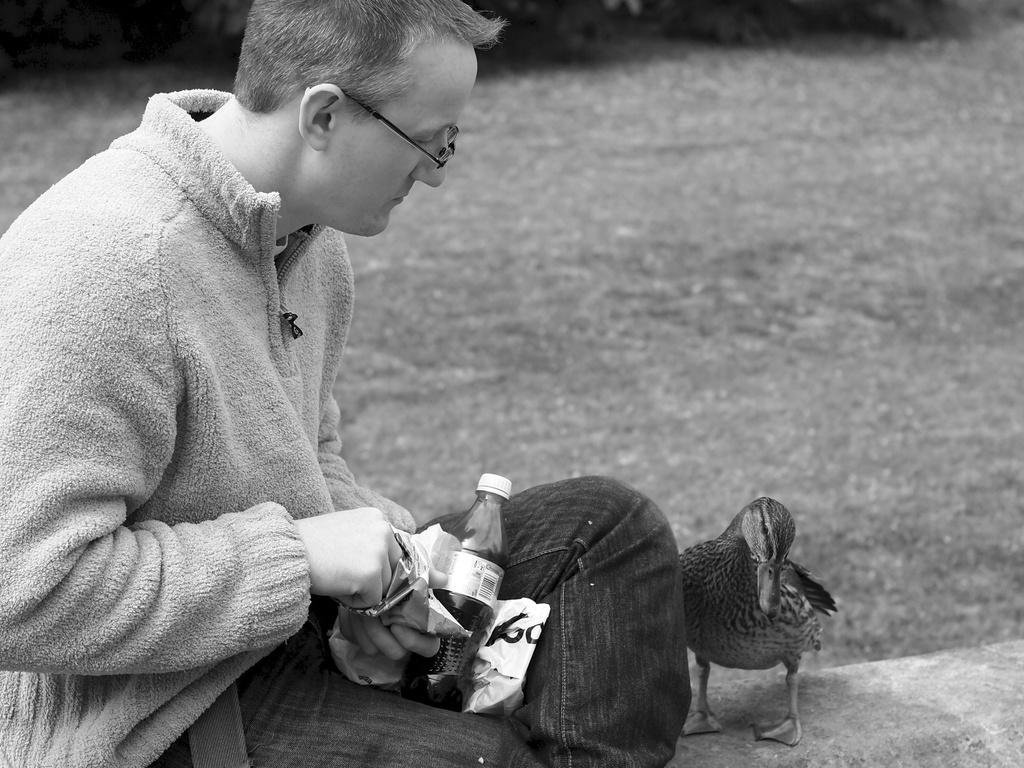Can you describe this image briefly? In the foreground of this image, on the left, there is a man sitting and holding a packet and we can also see a bottle and a cover on his laps. Beside him, there is a duck. In the background, it seems like a road. 